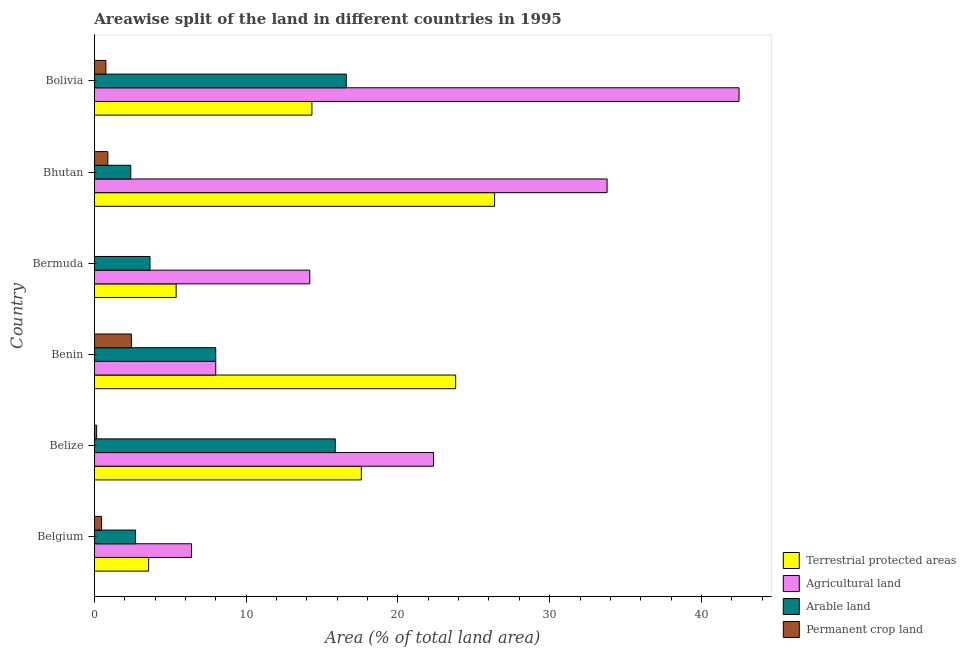How many different coloured bars are there?
Make the answer very short. 4. How many groups of bars are there?
Keep it short and to the point. 6. Are the number of bars per tick equal to the number of legend labels?
Your answer should be very brief. Yes. What is the label of the 6th group of bars from the top?
Your answer should be compact. Belgium. What is the percentage of area under arable land in Bolivia?
Your response must be concise. 16.6. Across all countries, what is the maximum percentage of area under permanent crop land?
Ensure brevity in your answer.  2.44. Across all countries, what is the minimum percentage of area under permanent crop land?
Keep it short and to the point. 0. In which country was the percentage of land under terrestrial protection maximum?
Provide a succinct answer. Bhutan. In which country was the percentage of area under arable land minimum?
Ensure brevity in your answer.  Bhutan. What is the total percentage of area under agricultural land in the graph?
Provide a short and direct response. 127.21. What is the difference between the percentage of land under terrestrial protection in Bermuda and that in Bhutan?
Offer a very short reply. -20.98. What is the difference between the percentage of area under permanent crop land in Bhutan and the percentage of area under arable land in Bolivia?
Ensure brevity in your answer.  -15.71. What is the average percentage of area under permanent crop land per country?
Make the answer very short. 0.79. What is the difference between the percentage of area under permanent crop land and percentage of land under terrestrial protection in Belize?
Offer a terse response. -17.44. In how many countries, is the percentage of area under agricultural land greater than 8 %?
Keep it short and to the point. 4. What is the ratio of the percentage of area under permanent crop land in Belize to that in Bhutan?
Ensure brevity in your answer.  0.17. Is the percentage of area under arable land in Belize less than that in Benin?
Make the answer very short. No. What is the difference between the highest and the second highest percentage of area under permanent crop land?
Give a very brief answer. 1.55. What is the difference between the highest and the lowest percentage of area under agricultural land?
Give a very brief answer. 36.08. What does the 1st bar from the top in Belgium represents?
Your answer should be compact. Permanent crop land. What does the 1st bar from the bottom in Belgium represents?
Offer a terse response. Terrestrial protected areas. How many bars are there?
Your response must be concise. 24. What is the difference between two consecutive major ticks on the X-axis?
Your response must be concise. 10. Are the values on the major ticks of X-axis written in scientific E-notation?
Make the answer very short. No. Does the graph contain any zero values?
Your answer should be compact. No. Does the graph contain grids?
Offer a terse response. No. Where does the legend appear in the graph?
Make the answer very short. Bottom right. How many legend labels are there?
Give a very brief answer. 4. What is the title of the graph?
Your answer should be compact. Areawise split of the land in different countries in 1995. What is the label or title of the X-axis?
Provide a succinct answer. Area (% of total land area). What is the Area (% of total land area) of Terrestrial protected areas in Belgium?
Provide a short and direct response. 3.58. What is the Area (% of total land area) of Agricultural land in Belgium?
Offer a terse response. 6.4. What is the Area (% of total land area) in Arable land in Belgium?
Offer a terse response. 2.72. What is the Area (% of total land area) of Permanent crop land in Belgium?
Ensure brevity in your answer.  0.48. What is the Area (% of total land area) in Terrestrial protected areas in Belize?
Your answer should be very brief. 17.59. What is the Area (% of total land area) in Agricultural land in Belize?
Offer a terse response. 22.35. What is the Area (% of total land area) in Arable land in Belize?
Ensure brevity in your answer.  15.87. What is the Area (% of total land area) in Permanent crop land in Belize?
Offer a terse response. 0.15. What is the Area (% of total land area) in Terrestrial protected areas in Benin?
Your response must be concise. 23.81. What is the Area (% of total land area) in Agricultural land in Benin?
Ensure brevity in your answer.  8. What is the Area (% of total land area) in Arable land in Benin?
Keep it short and to the point. 8. What is the Area (% of total land area) in Permanent crop land in Benin?
Your answer should be compact. 2.44. What is the Area (% of total land area) in Terrestrial protected areas in Bermuda?
Keep it short and to the point. 5.39. What is the Area (% of total land area) in Agricultural land in Bermuda?
Provide a succinct answer. 14.2. What is the Area (% of total land area) in Arable land in Bermuda?
Ensure brevity in your answer.  3.67. What is the Area (% of total land area) of Permanent crop land in Bermuda?
Offer a terse response. 0. What is the Area (% of total land area) in Terrestrial protected areas in Bhutan?
Your answer should be very brief. 26.38. What is the Area (% of total land area) of Agricultural land in Bhutan?
Your answer should be compact. 33.79. What is the Area (% of total land area) in Arable land in Bhutan?
Your response must be concise. 2.4. What is the Area (% of total land area) of Permanent crop land in Bhutan?
Keep it short and to the point. 0.89. What is the Area (% of total land area) in Terrestrial protected areas in Bolivia?
Keep it short and to the point. 14.34. What is the Area (% of total land area) of Agricultural land in Bolivia?
Offer a terse response. 42.48. What is the Area (% of total land area) of Arable land in Bolivia?
Keep it short and to the point. 16.6. What is the Area (% of total land area) of Permanent crop land in Bolivia?
Provide a short and direct response. 0.76. Across all countries, what is the maximum Area (% of total land area) of Terrestrial protected areas?
Provide a succinct answer. 26.38. Across all countries, what is the maximum Area (% of total land area) in Agricultural land?
Ensure brevity in your answer.  42.48. Across all countries, what is the maximum Area (% of total land area) of Arable land?
Give a very brief answer. 16.6. Across all countries, what is the maximum Area (% of total land area) of Permanent crop land?
Ensure brevity in your answer.  2.44. Across all countries, what is the minimum Area (% of total land area) of Terrestrial protected areas?
Your response must be concise. 3.58. Across all countries, what is the minimum Area (% of total land area) in Agricultural land?
Provide a short and direct response. 6.4. Across all countries, what is the minimum Area (% of total land area) of Arable land?
Keep it short and to the point. 2.4. Across all countries, what is the minimum Area (% of total land area) in Permanent crop land?
Ensure brevity in your answer.  0. What is the total Area (% of total land area) in Terrestrial protected areas in the graph?
Your answer should be compact. 91.08. What is the total Area (% of total land area) in Agricultural land in the graph?
Provide a succinct answer. 127.21. What is the total Area (% of total land area) of Arable land in the graph?
Your response must be concise. 49.26. What is the total Area (% of total land area) of Permanent crop land in the graph?
Your answer should be compact. 4.72. What is the difference between the Area (% of total land area) of Terrestrial protected areas in Belgium and that in Belize?
Your answer should be compact. -14.02. What is the difference between the Area (% of total land area) in Agricultural land in Belgium and that in Belize?
Offer a terse response. -15.95. What is the difference between the Area (% of total land area) of Arable land in Belgium and that in Belize?
Your answer should be compact. -13.16. What is the difference between the Area (% of total land area) of Permanent crop land in Belgium and that in Belize?
Make the answer very short. 0.33. What is the difference between the Area (% of total land area) in Terrestrial protected areas in Belgium and that in Benin?
Give a very brief answer. -20.23. What is the difference between the Area (% of total land area) of Agricultural land in Belgium and that in Benin?
Ensure brevity in your answer.  -1.6. What is the difference between the Area (% of total land area) in Arable land in Belgium and that in Benin?
Make the answer very short. -5.28. What is the difference between the Area (% of total land area) of Permanent crop land in Belgium and that in Benin?
Your answer should be compact. -1.96. What is the difference between the Area (% of total land area) in Terrestrial protected areas in Belgium and that in Bermuda?
Keep it short and to the point. -1.81. What is the difference between the Area (% of total land area) in Agricultural land in Belgium and that in Bermuda?
Provide a short and direct response. -7.8. What is the difference between the Area (% of total land area) in Arable land in Belgium and that in Bermuda?
Your answer should be very brief. -0.95. What is the difference between the Area (% of total land area) of Permanent crop land in Belgium and that in Bermuda?
Your response must be concise. 0.48. What is the difference between the Area (% of total land area) of Terrestrial protected areas in Belgium and that in Bhutan?
Provide a succinct answer. -22.8. What is the difference between the Area (% of total land area) of Agricultural land in Belgium and that in Bhutan?
Offer a terse response. -27.39. What is the difference between the Area (% of total land area) of Arable land in Belgium and that in Bhutan?
Your response must be concise. 0.32. What is the difference between the Area (% of total land area) of Permanent crop land in Belgium and that in Bhutan?
Provide a short and direct response. -0.41. What is the difference between the Area (% of total land area) in Terrestrial protected areas in Belgium and that in Bolivia?
Ensure brevity in your answer.  -10.76. What is the difference between the Area (% of total land area) in Agricultural land in Belgium and that in Bolivia?
Your answer should be compact. -36.08. What is the difference between the Area (% of total land area) in Arable land in Belgium and that in Bolivia?
Provide a short and direct response. -13.88. What is the difference between the Area (% of total land area) of Permanent crop land in Belgium and that in Bolivia?
Provide a short and direct response. -0.28. What is the difference between the Area (% of total land area) in Terrestrial protected areas in Belize and that in Benin?
Keep it short and to the point. -6.22. What is the difference between the Area (% of total land area) of Agricultural land in Belize and that in Benin?
Offer a terse response. 14.35. What is the difference between the Area (% of total land area) of Arable land in Belize and that in Benin?
Offer a very short reply. 7.87. What is the difference between the Area (% of total land area) in Permanent crop land in Belize and that in Benin?
Provide a short and direct response. -2.29. What is the difference between the Area (% of total land area) in Terrestrial protected areas in Belize and that in Bermuda?
Your answer should be compact. 12.2. What is the difference between the Area (% of total land area) of Agricultural land in Belize and that in Bermuda?
Make the answer very short. 8.15. What is the difference between the Area (% of total land area) in Arable land in Belize and that in Bermuda?
Provide a short and direct response. 12.21. What is the difference between the Area (% of total land area) in Permanent crop land in Belize and that in Bermuda?
Give a very brief answer. 0.15. What is the difference between the Area (% of total land area) in Terrestrial protected areas in Belize and that in Bhutan?
Make the answer very short. -8.78. What is the difference between the Area (% of total land area) of Agricultural land in Belize and that in Bhutan?
Provide a short and direct response. -11.44. What is the difference between the Area (% of total land area) of Arable land in Belize and that in Bhutan?
Provide a short and direct response. 13.47. What is the difference between the Area (% of total land area) of Permanent crop land in Belize and that in Bhutan?
Your answer should be very brief. -0.74. What is the difference between the Area (% of total land area) of Terrestrial protected areas in Belize and that in Bolivia?
Make the answer very short. 3.26. What is the difference between the Area (% of total land area) of Agricultural land in Belize and that in Bolivia?
Make the answer very short. -20.13. What is the difference between the Area (% of total land area) in Arable land in Belize and that in Bolivia?
Ensure brevity in your answer.  -0.73. What is the difference between the Area (% of total land area) in Permanent crop land in Belize and that in Bolivia?
Ensure brevity in your answer.  -0.61. What is the difference between the Area (% of total land area) in Terrestrial protected areas in Benin and that in Bermuda?
Your answer should be very brief. 18.42. What is the difference between the Area (% of total land area) in Agricultural land in Benin and that in Bermuda?
Provide a succinct answer. -6.2. What is the difference between the Area (% of total land area) of Arable land in Benin and that in Bermuda?
Provide a succinct answer. 4.33. What is the difference between the Area (% of total land area) in Permanent crop land in Benin and that in Bermuda?
Provide a succinct answer. 2.44. What is the difference between the Area (% of total land area) of Terrestrial protected areas in Benin and that in Bhutan?
Ensure brevity in your answer.  -2.57. What is the difference between the Area (% of total land area) of Agricultural land in Benin and that in Bhutan?
Provide a short and direct response. -25.79. What is the difference between the Area (% of total land area) in Arable land in Benin and that in Bhutan?
Your answer should be compact. 5.6. What is the difference between the Area (% of total land area) of Permanent crop land in Benin and that in Bhutan?
Provide a succinct answer. 1.55. What is the difference between the Area (% of total land area) in Terrestrial protected areas in Benin and that in Bolivia?
Give a very brief answer. 9.47. What is the difference between the Area (% of total land area) in Agricultural land in Benin and that in Bolivia?
Ensure brevity in your answer.  -34.48. What is the difference between the Area (% of total land area) in Arable land in Benin and that in Bolivia?
Ensure brevity in your answer.  -8.6. What is the difference between the Area (% of total land area) of Permanent crop land in Benin and that in Bolivia?
Provide a succinct answer. 1.68. What is the difference between the Area (% of total land area) of Terrestrial protected areas in Bermuda and that in Bhutan?
Offer a terse response. -20.99. What is the difference between the Area (% of total land area) in Agricultural land in Bermuda and that in Bhutan?
Give a very brief answer. -19.59. What is the difference between the Area (% of total land area) in Arable land in Bermuda and that in Bhutan?
Ensure brevity in your answer.  1.27. What is the difference between the Area (% of total land area) in Permanent crop land in Bermuda and that in Bhutan?
Offer a terse response. -0.89. What is the difference between the Area (% of total land area) in Terrestrial protected areas in Bermuda and that in Bolivia?
Make the answer very short. -8.95. What is the difference between the Area (% of total land area) in Agricultural land in Bermuda and that in Bolivia?
Your answer should be compact. -28.28. What is the difference between the Area (% of total land area) of Arable land in Bermuda and that in Bolivia?
Your answer should be compact. -12.93. What is the difference between the Area (% of total land area) of Permanent crop land in Bermuda and that in Bolivia?
Give a very brief answer. -0.76. What is the difference between the Area (% of total land area) of Terrestrial protected areas in Bhutan and that in Bolivia?
Provide a short and direct response. 12.04. What is the difference between the Area (% of total land area) of Agricultural land in Bhutan and that in Bolivia?
Give a very brief answer. -8.69. What is the difference between the Area (% of total land area) in Arable land in Bhutan and that in Bolivia?
Your answer should be compact. -14.2. What is the difference between the Area (% of total land area) in Permanent crop land in Bhutan and that in Bolivia?
Provide a succinct answer. 0.13. What is the difference between the Area (% of total land area) in Terrestrial protected areas in Belgium and the Area (% of total land area) in Agricultural land in Belize?
Provide a short and direct response. -18.77. What is the difference between the Area (% of total land area) of Terrestrial protected areas in Belgium and the Area (% of total land area) of Arable land in Belize?
Give a very brief answer. -12.3. What is the difference between the Area (% of total land area) of Terrestrial protected areas in Belgium and the Area (% of total land area) of Permanent crop land in Belize?
Ensure brevity in your answer.  3.42. What is the difference between the Area (% of total land area) in Agricultural land in Belgium and the Area (% of total land area) in Arable land in Belize?
Your response must be concise. -9.47. What is the difference between the Area (% of total land area) of Agricultural land in Belgium and the Area (% of total land area) of Permanent crop land in Belize?
Offer a terse response. 6.25. What is the difference between the Area (% of total land area) of Arable land in Belgium and the Area (% of total land area) of Permanent crop land in Belize?
Your answer should be compact. 2.57. What is the difference between the Area (% of total land area) in Terrestrial protected areas in Belgium and the Area (% of total land area) in Agricultural land in Benin?
Offer a very short reply. -4.42. What is the difference between the Area (% of total land area) of Terrestrial protected areas in Belgium and the Area (% of total land area) of Arable land in Benin?
Provide a succinct answer. -4.42. What is the difference between the Area (% of total land area) in Terrestrial protected areas in Belgium and the Area (% of total land area) in Permanent crop land in Benin?
Offer a terse response. 1.14. What is the difference between the Area (% of total land area) of Agricultural land in Belgium and the Area (% of total land area) of Arable land in Benin?
Make the answer very short. -1.6. What is the difference between the Area (% of total land area) in Agricultural land in Belgium and the Area (% of total land area) in Permanent crop land in Benin?
Give a very brief answer. 3.96. What is the difference between the Area (% of total land area) of Arable land in Belgium and the Area (% of total land area) of Permanent crop land in Benin?
Your response must be concise. 0.28. What is the difference between the Area (% of total land area) in Terrestrial protected areas in Belgium and the Area (% of total land area) in Agricultural land in Bermuda?
Offer a very short reply. -10.62. What is the difference between the Area (% of total land area) of Terrestrial protected areas in Belgium and the Area (% of total land area) of Arable land in Bermuda?
Give a very brief answer. -0.09. What is the difference between the Area (% of total land area) of Terrestrial protected areas in Belgium and the Area (% of total land area) of Permanent crop land in Bermuda?
Give a very brief answer. 3.58. What is the difference between the Area (% of total land area) in Agricultural land in Belgium and the Area (% of total land area) in Arable land in Bermuda?
Make the answer very short. 2.73. What is the difference between the Area (% of total land area) in Agricultural land in Belgium and the Area (% of total land area) in Permanent crop land in Bermuda?
Keep it short and to the point. 6.4. What is the difference between the Area (% of total land area) of Arable land in Belgium and the Area (% of total land area) of Permanent crop land in Bermuda?
Provide a short and direct response. 2.72. What is the difference between the Area (% of total land area) of Terrestrial protected areas in Belgium and the Area (% of total land area) of Agricultural land in Bhutan?
Keep it short and to the point. -30.21. What is the difference between the Area (% of total land area) of Terrestrial protected areas in Belgium and the Area (% of total land area) of Arable land in Bhutan?
Offer a very short reply. 1.18. What is the difference between the Area (% of total land area) of Terrestrial protected areas in Belgium and the Area (% of total land area) of Permanent crop land in Bhutan?
Provide a short and direct response. 2.69. What is the difference between the Area (% of total land area) in Agricultural land in Belgium and the Area (% of total land area) in Arable land in Bhutan?
Offer a terse response. 4. What is the difference between the Area (% of total land area) in Agricultural land in Belgium and the Area (% of total land area) in Permanent crop land in Bhutan?
Keep it short and to the point. 5.51. What is the difference between the Area (% of total land area) of Arable land in Belgium and the Area (% of total land area) of Permanent crop land in Bhutan?
Make the answer very short. 1.83. What is the difference between the Area (% of total land area) in Terrestrial protected areas in Belgium and the Area (% of total land area) in Agricultural land in Bolivia?
Provide a short and direct response. -38.9. What is the difference between the Area (% of total land area) in Terrestrial protected areas in Belgium and the Area (% of total land area) in Arable land in Bolivia?
Your answer should be compact. -13.02. What is the difference between the Area (% of total land area) in Terrestrial protected areas in Belgium and the Area (% of total land area) in Permanent crop land in Bolivia?
Offer a terse response. 2.82. What is the difference between the Area (% of total land area) of Agricultural land in Belgium and the Area (% of total land area) of Arable land in Bolivia?
Your response must be concise. -10.2. What is the difference between the Area (% of total land area) in Agricultural land in Belgium and the Area (% of total land area) in Permanent crop land in Bolivia?
Ensure brevity in your answer.  5.64. What is the difference between the Area (% of total land area) in Arable land in Belgium and the Area (% of total land area) in Permanent crop land in Bolivia?
Offer a terse response. 1.96. What is the difference between the Area (% of total land area) in Terrestrial protected areas in Belize and the Area (% of total land area) in Agricultural land in Benin?
Ensure brevity in your answer.  9.59. What is the difference between the Area (% of total land area) of Terrestrial protected areas in Belize and the Area (% of total land area) of Arable land in Benin?
Offer a terse response. 9.59. What is the difference between the Area (% of total land area) of Terrestrial protected areas in Belize and the Area (% of total land area) of Permanent crop land in Benin?
Make the answer very short. 15.15. What is the difference between the Area (% of total land area) of Agricultural land in Belize and the Area (% of total land area) of Arable land in Benin?
Your response must be concise. 14.35. What is the difference between the Area (% of total land area) in Agricultural land in Belize and the Area (% of total land area) in Permanent crop land in Benin?
Make the answer very short. 19.91. What is the difference between the Area (% of total land area) in Arable land in Belize and the Area (% of total land area) in Permanent crop land in Benin?
Your answer should be very brief. 13.43. What is the difference between the Area (% of total land area) of Terrestrial protected areas in Belize and the Area (% of total land area) of Agricultural land in Bermuda?
Offer a terse response. 3.4. What is the difference between the Area (% of total land area) in Terrestrial protected areas in Belize and the Area (% of total land area) in Arable land in Bermuda?
Your answer should be very brief. 13.92. What is the difference between the Area (% of total land area) of Terrestrial protected areas in Belize and the Area (% of total land area) of Permanent crop land in Bermuda?
Provide a short and direct response. 17.59. What is the difference between the Area (% of total land area) of Agricultural land in Belize and the Area (% of total land area) of Arable land in Bermuda?
Make the answer very short. 18.68. What is the difference between the Area (% of total land area) of Agricultural land in Belize and the Area (% of total land area) of Permanent crop land in Bermuda?
Provide a succinct answer. 22.35. What is the difference between the Area (% of total land area) in Arable land in Belize and the Area (% of total land area) in Permanent crop land in Bermuda?
Your answer should be very brief. 15.87. What is the difference between the Area (% of total land area) in Terrestrial protected areas in Belize and the Area (% of total land area) in Agricultural land in Bhutan?
Your answer should be compact. -16.19. What is the difference between the Area (% of total land area) in Terrestrial protected areas in Belize and the Area (% of total land area) in Arable land in Bhutan?
Provide a short and direct response. 15.19. What is the difference between the Area (% of total land area) in Terrestrial protected areas in Belize and the Area (% of total land area) in Permanent crop land in Bhutan?
Keep it short and to the point. 16.7. What is the difference between the Area (% of total land area) in Agricultural land in Belize and the Area (% of total land area) in Arable land in Bhutan?
Keep it short and to the point. 19.95. What is the difference between the Area (% of total land area) in Agricultural land in Belize and the Area (% of total land area) in Permanent crop land in Bhutan?
Ensure brevity in your answer.  21.46. What is the difference between the Area (% of total land area) in Arable land in Belize and the Area (% of total land area) in Permanent crop land in Bhutan?
Offer a terse response. 14.98. What is the difference between the Area (% of total land area) of Terrestrial protected areas in Belize and the Area (% of total land area) of Agricultural land in Bolivia?
Your answer should be compact. -24.89. What is the difference between the Area (% of total land area) in Terrestrial protected areas in Belize and the Area (% of total land area) in Arable land in Bolivia?
Provide a short and direct response. 0.99. What is the difference between the Area (% of total land area) of Terrestrial protected areas in Belize and the Area (% of total land area) of Permanent crop land in Bolivia?
Your answer should be very brief. 16.83. What is the difference between the Area (% of total land area) in Agricultural land in Belize and the Area (% of total land area) in Arable land in Bolivia?
Keep it short and to the point. 5.75. What is the difference between the Area (% of total land area) of Agricultural land in Belize and the Area (% of total land area) of Permanent crop land in Bolivia?
Give a very brief answer. 21.59. What is the difference between the Area (% of total land area) in Arable land in Belize and the Area (% of total land area) in Permanent crop land in Bolivia?
Your answer should be very brief. 15.12. What is the difference between the Area (% of total land area) of Terrestrial protected areas in Benin and the Area (% of total land area) of Agricultural land in Bermuda?
Provide a succinct answer. 9.61. What is the difference between the Area (% of total land area) in Terrestrial protected areas in Benin and the Area (% of total land area) in Arable land in Bermuda?
Ensure brevity in your answer.  20.14. What is the difference between the Area (% of total land area) in Terrestrial protected areas in Benin and the Area (% of total land area) in Permanent crop land in Bermuda?
Provide a short and direct response. 23.81. What is the difference between the Area (% of total land area) in Agricultural land in Benin and the Area (% of total land area) in Arable land in Bermuda?
Give a very brief answer. 4.33. What is the difference between the Area (% of total land area) of Agricultural land in Benin and the Area (% of total land area) of Permanent crop land in Bermuda?
Offer a very short reply. 8. What is the difference between the Area (% of total land area) of Arable land in Benin and the Area (% of total land area) of Permanent crop land in Bermuda?
Ensure brevity in your answer.  8. What is the difference between the Area (% of total land area) in Terrestrial protected areas in Benin and the Area (% of total land area) in Agricultural land in Bhutan?
Make the answer very short. -9.98. What is the difference between the Area (% of total land area) in Terrestrial protected areas in Benin and the Area (% of total land area) in Arable land in Bhutan?
Your answer should be very brief. 21.41. What is the difference between the Area (% of total land area) of Terrestrial protected areas in Benin and the Area (% of total land area) of Permanent crop land in Bhutan?
Offer a terse response. 22.92. What is the difference between the Area (% of total land area) of Agricultural land in Benin and the Area (% of total land area) of Arable land in Bhutan?
Offer a very short reply. 5.6. What is the difference between the Area (% of total land area) of Agricultural land in Benin and the Area (% of total land area) of Permanent crop land in Bhutan?
Offer a terse response. 7.11. What is the difference between the Area (% of total land area) in Arable land in Benin and the Area (% of total land area) in Permanent crop land in Bhutan?
Provide a short and direct response. 7.11. What is the difference between the Area (% of total land area) of Terrestrial protected areas in Benin and the Area (% of total land area) of Agricultural land in Bolivia?
Offer a terse response. -18.67. What is the difference between the Area (% of total land area) of Terrestrial protected areas in Benin and the Area (% of total land area) of Arable land in Bolivia?
Your response must be concise. 7.21. What is the difference between the Area (% of total land area) of Terrestrial protected areas in Benin and the Area (% of total land area) of Permanent crop land in Bolivia?
Offer a very short reply. 23.05. What is the difference between the Area (% of total land area) of Agricultural land in Benin and the Area (% of total land area) of Arable land in Bolivia?
Keep it short and to the point. -8.6. What is the difference between the Area (% of total land area) in Agricultural land in Benin and the Area (% of total land area) in Permanent crop land in Bolivia?
Make the answer very short. 7.24. What is the difference between the Area (% of total land area) of Arable land in Benin and the Area (% of total land area) of Permanent crop land in Bolivia?
Offer a very short reply. 7.24. What is the difference between the Area (% of total land area) of Terrestrial protected areas in Bermuda and the Area (% of total land area) of Agricultural land in Bhutan?
Keep it short and to the point. -28.4. What is the difference between the Area (% of total land area) of Terrestrial protected areas in Bermuda and the Area (% of total land area) of Arable land in Bhutan?
Your answer should be compact. 2.99. What is the difference between the Area (% of total land area) in Terrestrial protected areas in Bermuda and the Area (% of total land area) in Permanent crop land in Bhutan?
Make the answer very short. 4.5. What is the difference between the Area (% of total land area) in Agricultural land in Bermuda and the Area (% of total land area) in Arable land in Bhutan?
Offer a terse response. 11.8. What is the difference between the Area (% of total land area) in Agricultural land in Bermuda and the Area (% of total land area) in Permanent crop land in Bhutan?
Ensure brevity in your answer.  13.31. What is the difference between the Area (% of total land area) in Arable land in Bermuda and the Area (% of total land area) in Permanent crop land in Bhutan?
Your answer should be compact. 2.78. What is the difference between the Area (% of total land area) in Terrestrial protected areas in Bermuda and the Area (% of total land area) in Agricultural land in Bolivia?
Your response must be concise. -37.09. What is the difference between the Area (% of total land area) in Terrestrial protected areas in Bermuda and the Area (% of total land area) in Arable land in Bolivia?
Offer a very short reply. -11.21. What is the difference between the Area (% of total land area) of Terrestrial protected areas in Bermuda and the Area (% of total land area) of Permanent crop land in Bolivia?
Make the answer very short. 4.63. What is the difference between the Area (% of total land area) of Agricultural land in Bermuda and the Area (% of total land area) of Arable land in Bolivia?
Give a very brief answer. -2.41. What is the difference between the Area (% of total land area) of Agricultural land in Bermuda and the Area (% of total land area) of Permanent crop land in Bolivia?
Offer a very short reply. 13.44. What is the difference between the Area (% of total land area) of Arable land in Bermuda and the Area (% of total land area) of Permanent crop land in Bolivia?
Your answer should be very brief. 2.91. What is the difference between the Area (% of total land area) of Terrestrial protected areas in Bhutan and the Area (% of total land area) of Agricultural land in Bolivia?
Your answer should be compact. -16.11. What is the difference between the Area (% of total land area) of Terrestrial protected areas in Bhutan and the Area (% of total land area) of Arable land in Bolivia?
Keep it short and to the point. 9.77. What is the difference between the Area (% of total land area) of Terrestrial protected areas in Bhutan and the Area (% of total land area) of Permanent crop land in Bolivia?
Your response must be concise. 25.62. What is the difference between the Area (% of total land area) in Agricultural land in Bhutan and the Area (% of total land area) in Arable land in Bolivia?
Make the answer very short. 17.18. What is the difference between the Area (% of total land area) of Agricultural land in Bhutan and the Area (% of total land area) of Permanent crop land in Bolivia?
Provide a short and direct response. 33.03. What is the difference between the Area (% of total land area) in Arable land in Bhutan and the Area (% of total land area) in Permanent crop land in Bolivia?
Offer a very short reply. 1.64. What is the average Area (% of total land area) in Terrestrial protected areas per country?
Make the answer very short. 15.18. What is the average Area (% of total land area) in Agricultural land per country?
Your answer should be compact. 21.2. What is the average Area (% of total land area) in Arable land per country?
Provide a succinct answer. 8.21. What is the average Area (% of total land area) of Permanent crop land per country?
Make the answer very short. 0.79. What is the difference between the Area (% of total land area) in Terrestrial protected areas and Area (% of total land area) in Agricultural land in Belgium?
Offer a terse response. -2.82. What is the difference between the Area (% of total land area) in Terrestrial protected areas and Area (% of total land area) in Arable land in Belgium?
Provide a succinct answer. 0.86. What is the difference between the Area (% of total land area) of Terrestrial protected areas and Area (% of total land area) of Permanent crop land in Belgium?
Make the answer very short. 3.1. What is the difference between the Area (% of total land area) in Agricultural land and Area (% of total land area) in Arable land in Belgium?
Your response must be concise. 3.68. What is the difference between the Area (% of total land area) in Agricultural land and Area (% of total land area) in Permanent crop land in Belgium?
Offer a very short reply. 5.92. What is the difference between the Area (% of total land area) in Arable land and Area (% of total land area) in Permanent crop land in Belgium?
Your answer should be very brief. 2.24. What is the difference between the Area (% of total land area) of Terrestrial protected areas and Area (% of total land area) of Agricultural land in Belize?
Provide a short and direct response. -4.76. What is the difference between the Area (% of total land area) of Terrestrial protected areas and Area (% of total land area) of Arable land in Belize?
Ensure brevity in your answer.  1.72. What is the difference between the Area (% of total land area) in Terrestrial protected areas and Area (% of total land area) in Permanent crop land in Belize?
Make the answer very short. 17.44. What is the difference between the Area (% of total land area) of Agricultural land and Area (% of total land area) of Arable land in Belize?
Ensure brevity in your answer.  6.47. What is the difference between the Area (% of total land area) of Agricultural land and Area (% of total land area) of Permanent crop land in Belize?
Give a very brief answer. 22.2. What is the difference between the Area (% of total land area) of Arable land and Area (% of total land area) of Permanent crop land in Belize?
Give a very brief answer. 15.72. What is the difference between the Area (% of total land area) in Terrestrial protected areas and Area (% of total land area) in Agricultural land in Benin?
Give a very brief answer. 15.81. What is the difference between the Area (% of total land area) in Terrestrial protected areas and Area (% of total land area) in Arable land in Benin?
Give a very brief answer. 15.81. What is the difference between the Area (% of total land area) in Terrestrial protected areas and Area (% of total land area) in Permanent crop land in Benin?
Your answer should be compact. 21.37. What is the difference between the Area (% of total land area) of Agricultural land and Area (% of total land area) of Permanent crop land in Benin?
Provide a succinct answer. 5.56. What is the difference between the Area (% of total land area) of Arable land and Area (% of total land area) of Permanent crop land in Benin?
Keep it short and to the point. 5.56. What is the difference between the Area (% of total land area) in Terrestrial protected areas and Area (% of total land area) in Agricultural land in Bermuda?
Provide a short and direct response. -8.81. What is the difference between the Area (% of total land area) of Terrestrial protected areas and Area (% of total land area) of Arable land in Bermuda?
Keep it short and to the point. 1.72. What is the difference between the Area (% of total land area) in Terrestrial protected areas and Area (% of total land area) in Permanent crop land in Bermuda?
Your response must be concise. 5.39. What is the difference between the Area (% of total land area) in Agricultural land and Area (% of total land area) in Arable land in Bermuda?
Your answer should be compact. 10.53. What is the difference between the Area (% of total land area) of Agricultural land and Area (% of total land area) of Permanent crop land in Bermuda?
Provide a succinct answer. 14.19. What is the difference between the Area (% of total land area) of Arable land and Area (% of total land area) of Permanent crop land in Bermuda?
Your response must be concise. 3.67. What is the difference between the Area (% of total land area) in Terrestrial protected areas and Area (% of total land area) in Agricultural land in Bhutan?
Ensure brevity in your answer.  -7.41. What is the difference between the Area (% of total land area) in Terrestrial protected areas and Area (% of total land area) in Arable land in Bhutan?
Give a very brief answer. 23.98. What is the difference between the Area (% of total land area) of Terrestrial protected areas and Area (% of total land area) of Permanent crop land in Bhutan?
Provide a short and direct response. 25.48. What is the difference between the Area (% of total land area) in Agricultural land and Area (% of total land area) in Arable land in Bhutan?
Your response must be concise. 31.39. What is the difference between the Area (% of total land area) in Agricultural land and Area (% of total land area) in Permanent crop land in Bhutan?
Give a very brief answer. 32.9. What is the difference between the Area (% of total land area) in Arable land and Area (% of total land area) in Permanent crop land in Bhutan?
Keep it short and to the point. 1.51. What is the difference between the Area (% of total land area) of Terrestrial protected areas and Area (% of total land area) of Agricultural land in Bolivia?
Make the answer very short. -28.14. What is the difference between the Area (% of total land area) in Terrestrial protected areas and Area (% of total land area) in Arable land in Bolivia?
Give a very brief answer. -2.26. What is the difference between the Area (% of total land area) of Terrestrial protected areas and Area (% of total land area) of Permanent crop land in Bolivia?
Make the answer very short. 13.58. What is the difference between the Area (% of total land area) in Agricultural land and Area (% of total land area) in Arable land in Bolivia?
Offer a terse response. 25.88. What is the difference between the Area (% of total land area) in Agricultural land and Area (% of total land area) in Permanent crop land in Bolivia?
Keep it short and to the point. 41.72. What is the difference between the Area (% of total land area) in Arable land and Area (% of total land area) in Permanent crop land in Bolivia?
Give a very brief answer. 15.84. What is the ratio of the Area (% of total land area) of Terrestrial protected areas in Belgium to that in Belize?
Make the answer very short. 0.2. What is the ratio of the Area (% of total land area) of Agricultural land in Belgium to that in Belize?
Your answer should be compact. 0.29. What is the ratio of the Area (% of total land area) of Arable land in Belgium to that in Belize?
Your answer should be compact. 0.17. What is the ratio of the Area (% of total land area) in Permanent crop land in Belgium to that in Belize?
Make the answer very short. 3.13. What is the ratio of the Area (% of total land area) of Terrestrial protected areas in Belgium to that in Benin?
Give a very brief answer. 0.15. What is the ratio of the Area (% of total land area) in Agricultural land in Belgium to that in Benin?
Ensure brevity in your answer.  0.8. What is the ratio of the Area (% of total land area) in Arable land in Belgium to that in Benin?
Provide a short and direct response. 0.34. What is the ratio of the Area (% of total land area) in Permanent crop land in Belgium to that in Benin?
Offer a terse response. 0.2. What is the ratio of the Area (% of total land area) in Terrestrial protected areas in Belgium to that in Bermuda?
Make the answer very short. 0.66. What is the ratio of the Area (% of total land area) of Agricultural land in Belgium to that in Bermuda?
Give a very brief answer. 0.45. What is the ratio of the Area (% of total land area) in Arable land in Belgium to that in Bermuda?
Your answer should be compact. 0.74. What is the ratio of the Area (% of total land area) of Permanent crop land in Belgium to that in Bermuda?
Make the answer very short. 270.55. What is the ratio of the Area (% of total land area) of Terrestrial protected areas in Belgium to that in Bhutan?
Provide a succinct answer. 0.14. What is the ratio of the Area (% of total land area) of Agricultural land in Belgium to that in Bhutan?
Make the answer very short. 0.19. What is the ratio of the Area (% of total land area) in Arable land in Belgium to that in Bhutan?
Your answer should be very brief. 1.13. What is the ratio of the Area (% of total land area) of Permanent crop land in Belgium to that in Bhutan?
Make the answer very short. 0.54. What is the ratio of the Area (% of total land area) of Terrestrial protected areas in Belgium to that in Bolivia?
Provide a succinct answer. 0.25. What is the ratio of the Area (% of total land area) in Agricultural land in Belgium to that in Bolivia?
Provide a short and direct response. 0.15. What is the ratio of the Area (% of total land area) of Arable land in Belgium to that in Bolivia?
Your answer should be compact. 0.16. What is the ratio of the Area (% of total land area) in Permanent crop land in Belgium to that in Bolivia?
Your answer should be very brief. 0.63. What is the ratio of the Area (% of total land area) in Terrestrial protected areas in Belize to that in Benin?
Your answer should be very brief. 0.74. What is the ratio of the Area (% of total land area) of Agricultural land in Belize to that in Benin?
Keep it short and to the point. 2.79. What is the ratio of the Area (% of total land area) of Arable land in Belize to that in Benin?
Provide a short and direct response. 1.98. What is the ratio of the Area (% of total land area) of Permanent crop land in Belize to that in Benin?
Offer a terse response. 0.06. What is the ratio of the Area (% of total land area) of Terrestrial protected areas in Belize to that in Bermuda?
Offer a terse response. 3.26. What is the ratio of the Area (% of total land area) in Agricultural land in Belize to that in Bermuda?
Provide a short and direct response. 1.57. What is the ratio of the Area (% of total land area) of Arable land in Belize to that in Bermuda?
Your response must be concise. 4.33. What is the ratio of the Area (% of total land area) in Permanent crop land in Belize to that in Bermuda?
Offer a terse response. 86.32. What is the ratio of the Area (% of total land area) of Terrestrial protected areas in Belize to that in Bhutan?
Give a very brief answer. 0.67. What is the ratio of the Area (% of total land area) in Agricultural land in Belize to that in Bhutan?
Offer a terse response. 0.66. What is the ratio of the Area (% of total land area) of Arable land in Belize to that in Bhutan?
Offer a very short reply. 6.61. What is the ratio of the Area (% of total land area) in Permanent crop land in Belize to that in Bhutan?
Provide a succinct answer. 0.17. What is the ratio of the Area (% of total land area) of Terrestrial protected areas in Belize to that in Bolivia?
Provide a succinct answer. 1.23. What is the ratio of the Area (% of total land area) in Agricultural land in Belize to that in Bolivia?
Your answer should be compact. 0.53. What is the ratio of the Area (% of total land area) of Arable land in Belize to that in Bolivia?
Offer a very short reply. 0.96. What is the ratio of the Area (% of total land area) in Permanent crop land in Belize to that in Bolivia?
Your answer should be very brief. 0.2. What is the ratio of the Area (% of total land area) of Terrestrial protected areas in Benin to that in Bermuda?
Offer a terse response. 4.42. What is the ratio of the Area (% of total land area) in Agricultural land in Benin to that in Bermuda?
Keep it short and to the point. 0.56. What is the ratio of the Area (% of total land area) of Arable land in Benin to that in Bermuda?
Offer a very short reply. 2.18. What is the ratio of the Area (% of total land area) of Permanent crop land in Benin to that in Bermuda?
Provide a short and direct response. 1383.62. What is the ratio of the Area (% of total land area) in Terrestrial protected areas in Benin to that in Bhutan?
Your response must be concise. 0.9. What is the ratio of the Area (% of total land area) in Agricultural land in Benin to that in Bhutan?
Your answer should be compact. 0.24. What is the ratio of the Area (% of total land area) in Arable land in Benin to that in Bhutan?
Make the answer very short. 3.33. What is the ratio of the Area (% of total land area) of Permanent crop land in Benin to that in Bhutan?
Your answer should be compact. 2.74. What is the ratio of the Area (% of total land area) in Terrestrial protected areas in Benin to that in Bolivia?
Make the answer very short. 1.66. What is the ratio of the Area (% of total land area) in Agricultural land in Benin to that in Bolivia?
Give a very brief answer. 0.19. What is the ratio of the Area (% of total land area) in Arable land in Benin to that in Bolivia?
Provide a short and direct response. 0.48. What is the ratio of the Area (% of total land area) of Permanent crop land in Benin to that in Bolivia?
Provide a short and direct response. 3.22. What is the ratio of the Area (% of total land area) in Terrestrial protected areas in Bermuda to that in Bhutan?
Offer a very short reply. 0.2. What is the ratio of the Area (% of total land area) of Agricultural land in Bermuda to that in Bhutan?
Give a very brief answer. 0.42. What is the ratio of the Area (% of total land area) in Arable land in Bermuda to that in Bhutan?
Keep it short and to the point. 1.53. What is the ratio of the Area (% of total land area) in Permanent crop land in Bermuda to that in Bhutan?
Offer a terse response. 0. What is the ratio of the Area (% of total land area) of Terrestrial protected areas in Bermuda to that in Bolivia?
Keep it short and to the point. 0.38. What is the ratio of the Area (% of total land area) of Agricultural land in Bermuda to that in Bolivia?
Make the answer very short. 0.33. What is the ratio of the Area (% of total land area) in Arable land in Bermuda to that in Bolivia?
Provide a short and direct response. 0.22. What is the ratio of the Area (% of total land area) of Permanent crop land in Bermuda to that in Bolivia?
Keep it short and to the point. 0. What is the ratio of the Area (% of total land area) in Terrestrial protected areas in Bhutan to that in Bolivia?
Your answer should be compact. 1.84. What is the ratio of the Area (% of total land area) of Agricultural land in Bhutan to that in Bolivia?
Offer a terse response. 0.8. What is the ratio of the Area (% of total land area) in Arable land in Bhutan to that in Bolivia?
Your response must be concise. 0.14. What is the ratio of the Area (% of total land area) of Permanent crop land in Bhutan to that in Bolivia?
Give a very brief answer. 1.17. What is the difference between the highest and the second highest Area (% of total land area) in Terrestrial protected areas?
Ensure brevity in your answer.  2.57. What is the difference between the highest and the second highest Area (% of total land area) in Agricultural land?
Offer a very short reply. 8.69. What is the difference between the highest and the second highest Area (% of total land area) in Arable land?
Your answer should be very brief. 0.73. What is the difference between the highest and the second highest Area (% of total land area) of Permanent crop land?
Make the answer very short. 1.55. What is the difference between the highest and the lowest Area (% of total land area) in Terrestrial protected areas?
Ensure brevity in your answer.  22.8. What is the difference between the highest and the lowest Area (% of total land area) of Agricultural land?
Offer a terse response. 36.08. What is the difference between the highest and the lowest Area (% of total land area) of Arable land?
Offer a very short reply. 14.2. What is the difference between the highest and the lowest Area (% of total land area) of Permanent crop land?
Your answer should be very brief. 2.44. 